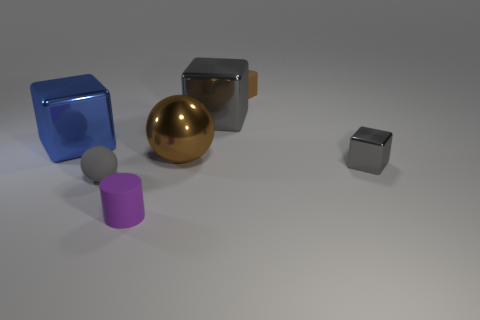Subtract 2 spheres. How many spheres are left? 0 Subtract all large gray metallic blocks. How many blocks are left? 3 Add 3 tiny purple objects. How many objects exist? 10 Subtract all red cubes. Subtract all brown spheres. How many cubes are left? 4 Subtract all gray cubes. How many green spheres are left? 0 Subtract all tiny gray metallic cylinders. Subtract all small gray matte objects. How many objects are left? 6 Add 4 purple matte cylinders. How many purple matte cylinders are left? 5 Add 2 purple cylinders. How many purple cylinders exist? 3 Subtract all brown cubes. How many cubes are left? 3 Subtract 0 cyan blocks. How many objects are left? 7 